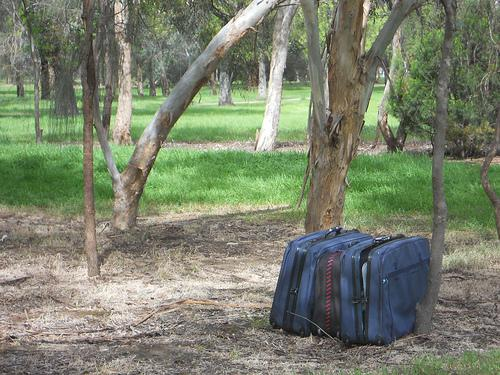Question: where is the luggage?
Choices:
A. By the doorway.
B. In the closet.
C. Beside the tree.
D. On the conveyor belt.
Answer with the letter. Answer: C Question: how many bags of luggage?
Choices:
A. Four.
B. Three.
C. Five.
D. Six.
Answer with the letter. Answer: B Question: what is all over the ground?
Choices:
A. Dirt.
B. Dead leaves.
C. Sticks and twigs.
D. Rocks.
Answer with the letter. Answer: C Question: where was this photo taken?
Choices:
A. A forest.
B. My Grandma's house.
C. At School.
D. At our wedding.
Answer with the letter. Answer: A 